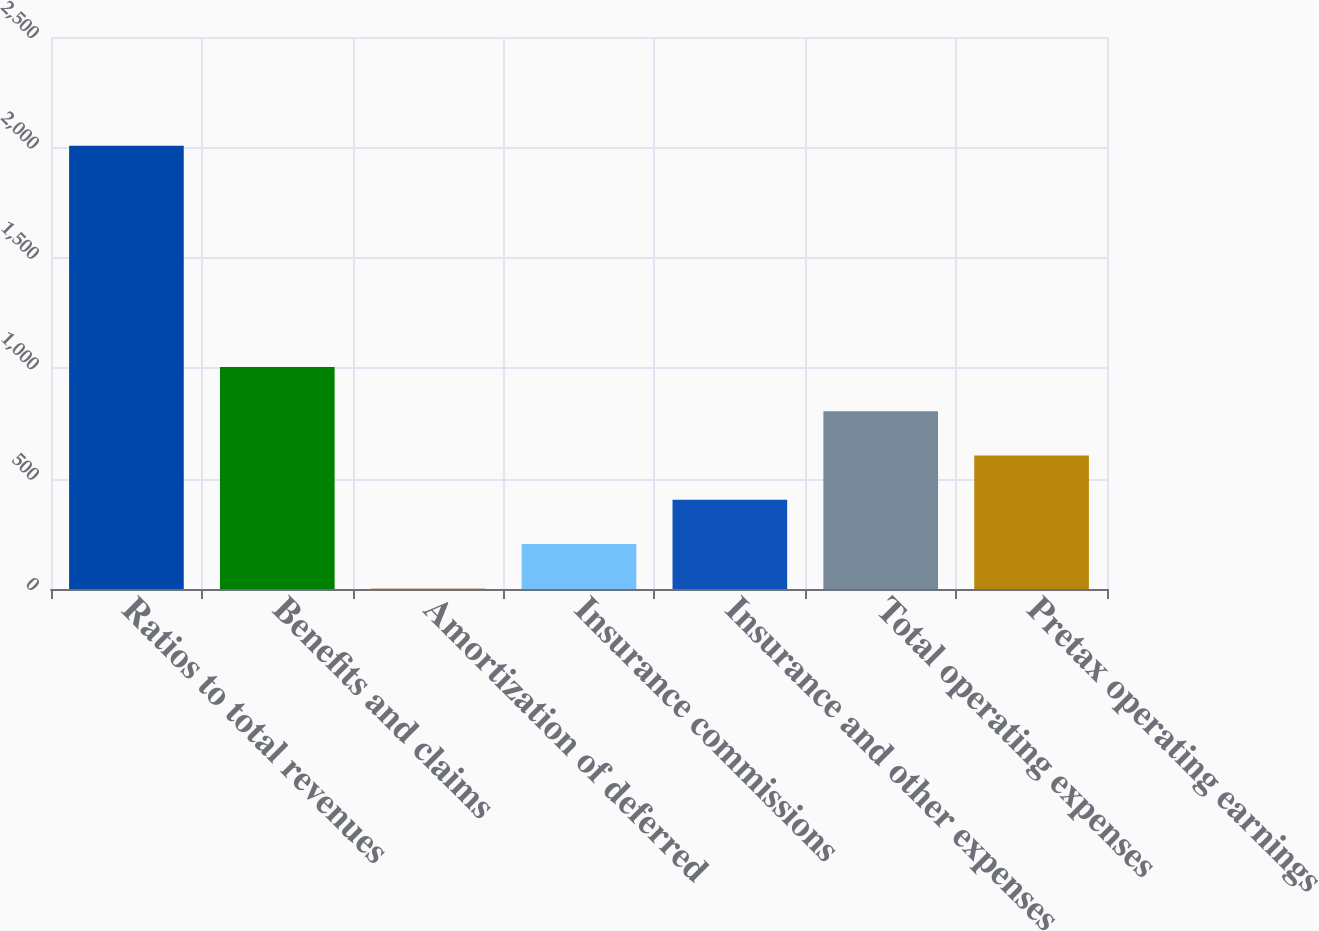Convert chart. <chart><loc_0><loc_0><loc_500><loc_500><bar_chart><fcel>Ratios to total revenues<fcel>Benefits and claims<fcel>Amortization of deferred<fcel>Insurance commissions<fcel>Insurance and other expenses<fcel>Total operating expenses<fcel>Pretax operating earnings<nl><fcel>2007<fcel>1004.95<fcel>2.9<fcel>203.31<fcel>403.72<fcel>804.54<fcel>604.13<nl></chart> 